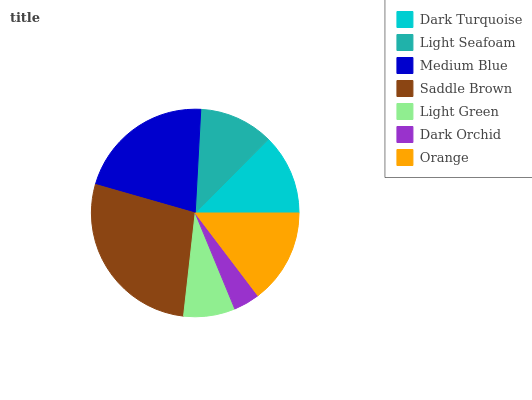Is Dark Orchid the minimum?
Answer yes or no. Yes. Is Saddle Brown the maximum?
Answer yes or no. Yes. Is Light Seafoam the minimum?
Answer yes or no. No. Is Light Seafoam the maximum?
Answer yes or no. No. Is Dark Turquoise greater than Light Seafoam?
Answer yes or no. Yes. Is Light Seafoam less than Dark Turquoise?
Answer yes or no. Yes. Is Light Seafoam greater than Dark Turquoise?
Answer yes or no. No. Is Dark Turquoise less than Light Seafoam?
Answer yes or no. No. Is Dark Turquoise the high median?
Answer yes or no. Yes. Is Dark Turquoise the low median?
Answer yes or no. Yes. Is Medium Blue the high median?
Answer yes or no. No. Is Dark Orchid the low median?
Answer yes or no. No. 